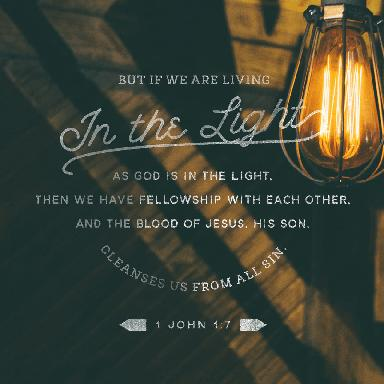What is the message of this verse? 1 John 1:7 speaks to the transformative power of living a life aligned with God’s truth. It addresses the concept of spiritual illumination, which brings into fellowship with others who walk the same path, and explains that it is through Jesus' sacrifice that we are cleansed from our sins. The verse serves as a compelling call to embrace a life of righteousness, transparency, and community, assuring us of the redemptive grace made available through Jesus Christ. 